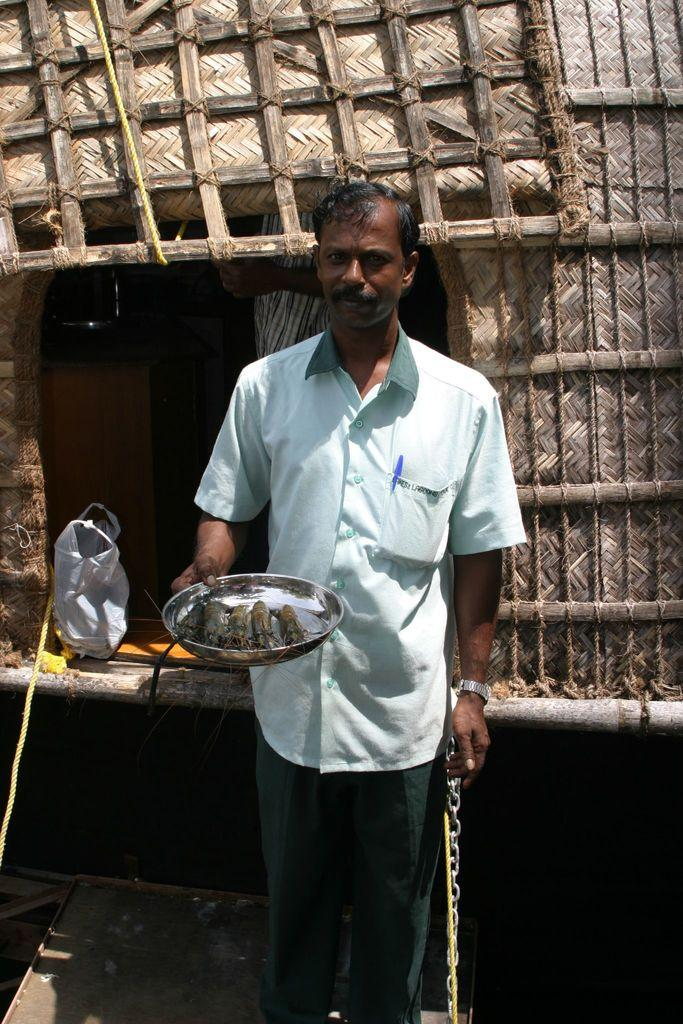Who is present in the image? There is a man in the image. What is the man holding in the image? The man is holding a plate. What event is taking place in the image? The image takes place at a prom. What can be seen in the background of the image? There is a hut in the background of the image. Can you see the man's mom in the image? There is no indication of the man's mom being present in the image. What type of animals can be seen at the zoo in the image? There is no zoo present in the image; it features a man holding a plate at a prom with a hut in the background. 